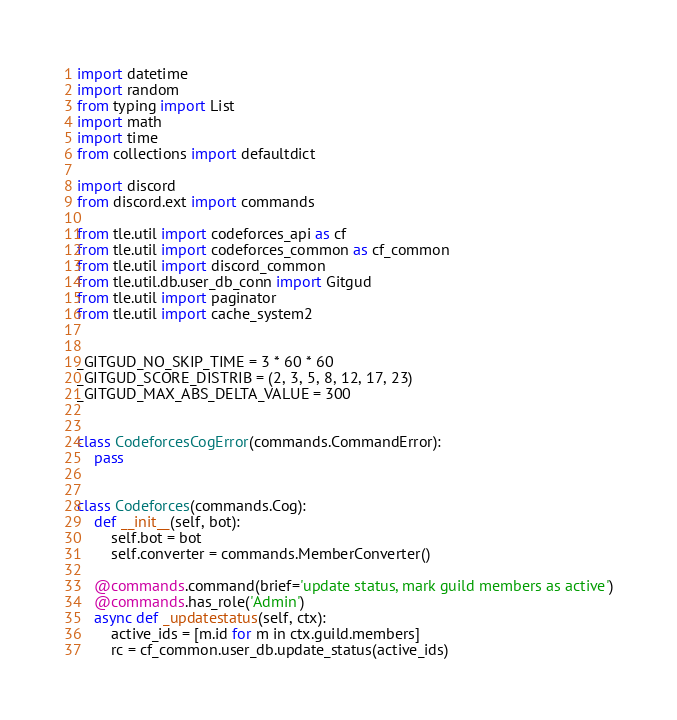Convert code to text. <code><loc_0><loc_0><loc_500><loc_500><_Python_>import datetime
import random
from typing import List
import math
import time
from collections import defaultdict

import discord
from discord.ext import commands

from tle.util import codeforces_api as cf
from tle.util import codeforces_common as cf_common
from tle.util import discord_common
from tle.util.db.user_db_conn import Gitgud
from tle.util import paginator
from tle.util import cache_system2


_GITGUD_NO_SKIP_TIME = 3 * 60 * 60
_GITGUD_SCORE_DISTRIB = (2, 3, 5, 8, 12, 17, 23)
_GITGUD_MAX_ABS_DELTA_VALUE = 300


class CodeforcesCogError(commands.CommandError):
    pass


class Codeforces(commands.Cog):
    def __init__(self, bot):
        self.bot = bot
        self.converter = commands.MemberConverter()

    @commands.command(brief='update status, mark guild members as active')
    @commands.has_role('Admin')
    async def _updatestatus(self, ctx):
        active_ids = [m.id for m in ctx.guild.members]
        rc = cf_common.user_db.update_status(active_ids)</code> 